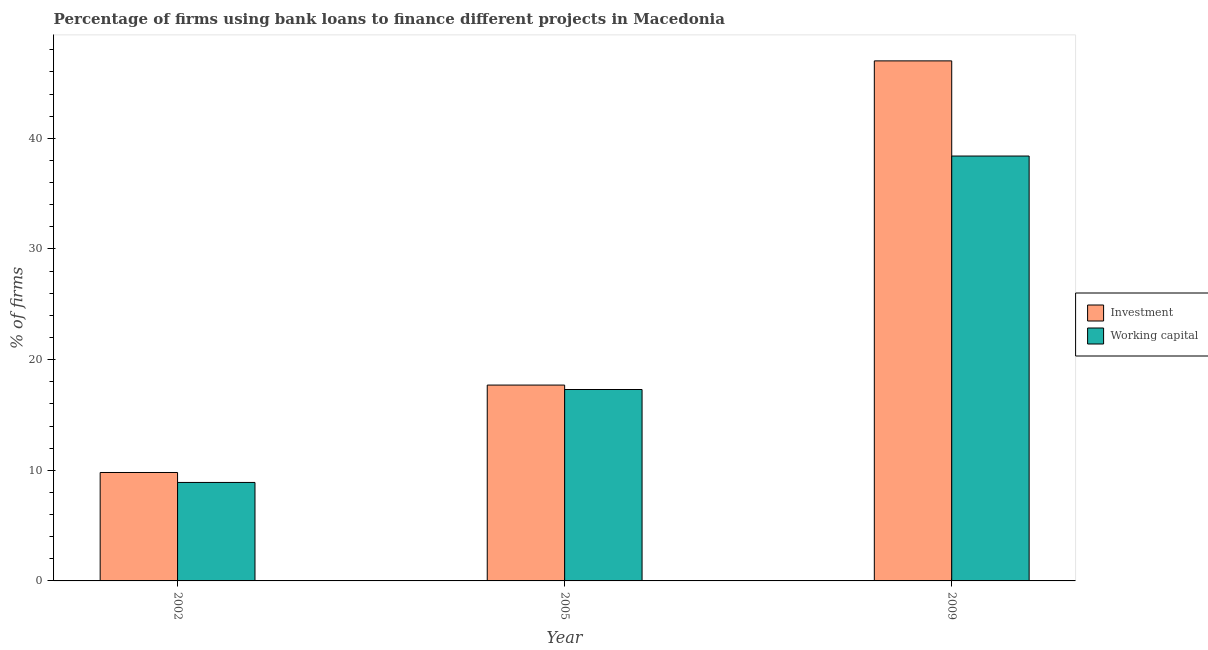How many bars are there on the 1st tick from the right?
Ensure brevity in your answer.  2. What is the label of the 3rd group of bars from the left?
Provide a succinct answer. 2009. In how many cases, is the number of bars for a given year not equal to the number of legend labels?
Offer a terse response. 0. What is the percentage of firms using banks to finance working capital in 2005?
Offer a very short reply. 17.3. Across all years, what is the maximum percentage of firms using banks to finance working capital?
Offer a very short reply. 38.4. In which year was the percentage of firms using banks to finance investment maximum?
Your response must be concise. 2009. What is the total percentage of firms using banks to finance investment in the graph?
Your answer should be very brief. 74.5. What is the difference between the percentage of firms using banks to finance investment in 2002 and that in 2005?
Provide a succinct answer. -7.9. What is the difference between the percentage of firms using banks to finance working capital in 2009 and the percentage of firms using banks to finance investment in 2002?
Ensure brevity in your answer.  29.5. What is the average percentage of firms using banks to finance working capital per year?
Give a very brief answer. 21.53. In how many years, is the percentage of firms using banks to finance investment greater than 16 %?
Ensure brevity in your answer.  2. What is the ratio of the percentage of firms using banks to finance working capital in 2002 to that in 2005?
Your response must be concise. 0.51. Is the percentage of firms using banks to finance investment in 2002 less than that in 2009?
Ensure brevity in your answer.  Yes. Is the difference between the percentage of firms using banks to finance investment in 2002 and 2009 greater than the difference between the percentage of firms using banks to finance working capital in 2002 and 2009?
Provide a short and direct response. No. What is the difference between the highest and the second highest percentage of firms using banks to finance working capital?
Provide a short and direct response. 21.1. What is the difference between the highest and the lowest percentage of firms using banks to finance investment?
Your answer should be very brief. 37.2. In how many years, is the percentage of firms using banks to finance investment greater than the average percentage of firms using banks to finance investment taken over all years?
Your answer should be compact. 1. Is the sum of the percentage of firms using banks to finance working capital in 2002 and 2009 greater than the maximum percentage of firms using banks to finance investment across all years?
Make the answer very short. Yes. What does the 2nd bar from the left in 2002 represents?
Your answer should be very brief. Working capital. What does the 1st bar from the right in 2009 represents?
Your answer should be very brief. Working capital. Are all the bars in the graph horizontal?
Your answer should be compact. No. How many years are there in the graph?
Keep it short and to the point. 3. Does the graph contain any zero values?
Keep it short and to the point. No. Does the graph contain grids?
Offer a terse response. No. Where does the legend appear in the graph?
Give a very brief answer. Center right. How many legend labels are there?
Offer a terse response. 2. What is the title of the graph?
Keep it short and to the point. Percentage of firms using bank loans to finance different projects in Macedonia. Does "Attending school" appear as one of the legend labels in the graph?
Your answer should be very brief. No. What is the label or title of the Y-axis?
Keep it short and to the point. % of firms. What is the % of firms of Investment in 2005?
Offer a very short reply. 17.7. What is the % of firms of Investment in 2009?
Provide a short and direct response. 47. What is the % of firms of Working capital in 2009?
Your answer should be very brief. 38.4. Across all years, what is the maximum % of firms in Investment?
Your answer should be very brief. 47. Across all years, what is the maximum % of firms in Working capital?
Keep it short and to the point. 38.4. What is the total % of firms in Investment in the graph?
Your response must be concise. 74.5. What is the total % of firms of Working capital in the graph?
Your response must be concise. 64.6. What is the difference between the % of firms in Investment in 2002 and that in 2009?
Your answer should be very brief. -37.2. What is the difference between the % of firms of Working capital in 2002 and that in 2009?
Your answer should be compact. -29.5. What is the difference between the % of firms in Investment in 2005 and that in 2009?
Give a very brief answer. -29.3. What is the difference between the % of firms of Working capital in 2005 and that in 2009?
Offer a terse response. -21.1. What is the difference between the % of firms in Investment in 2002 and the % of firms in Working capital in 2005?
Your answer should be compact. -7.5. What is the difference between the % of firms in Investment in 2002 and the % of firms in Working capital in 2009?
Offer a very short reply. -28.6. What is the difference between the % of firms in Investment in 2005 and the % of firms in Working capital in 2009?
Your response must be concise. -20.7. What is the average % of firms in Investment per year?
Ensure brevity in your answer.  24.83. What is the average % of firms of Working capital per year?
Your answer should be compact. 21.53. What is the ratio of the % of firms of Investment in 2002 to that in 2005?
Provide a short and direct response. 0.55. What is the ratio of the % of firms of Working capital in 2002 to that in 2005?
Give a very brief answer. 0.51. What is the ratio of the % of firms in Investment in 2002 to that in 2009?
Ensure brevity in your answer.  0.21. What is the ratio of the % of firms in Working capital in 2002 to that in 2009?
Keep it short and to the point. 0.23. What is the ratio of the % of firms in Investment in 2005 to that in 2009?
Give a very brief answer. 0.38. What is the ratio of the % of firms in Working capital in 2005 to that in 2009?
Your answer should be very brief. 0.45. What is the difference between the highest and the second highest % of firms of Investment?
Offer a very short reply. 29.3. What is the difference between the highest and the second highest % of firms in Working capital?
Your answer should be very brief. 21.1. What is the difference between the highest and the lowest % of firms of Investment?
Provide a succinct answer. 37.2. What is the difference between the highest and the lowest % of firms of Working capital?
Your answer should be very brief. 29.5. 